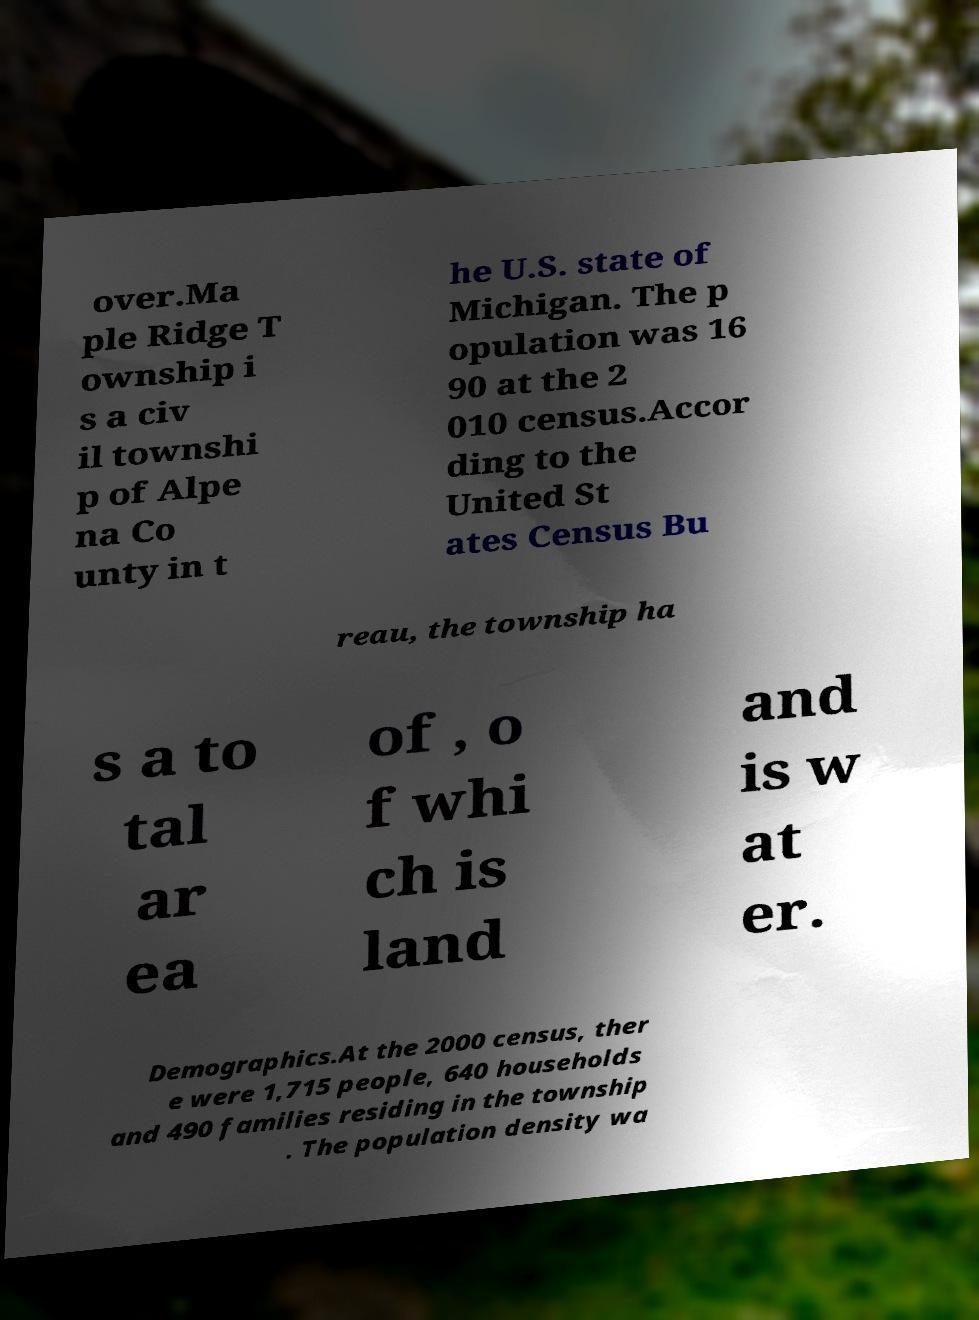Please identify and transcribe the text found in this image. over.Ma ple Ridge T ownship i s a civ il townshi p of Alpe na Co unty in t he U.S. state of Michigan. The p opulation was 16 90 at the 2 010 census.Accor ding to the United St ates Census Bu reau, the township ha s a to tal ar ea of , o f whi ch is land and is w at er. Demographics.At the 2000 census, ther e were 1,715 people, 640 households and 490 families residing in the township . The population density wa 